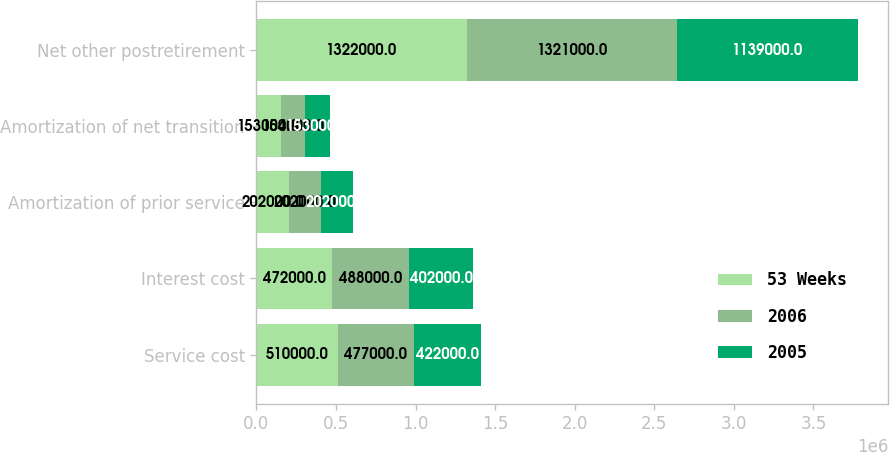<chart> <loc_0><loc_0><loc_500><loc_500><stacked_bar_chart><ecel><fcel>Service cost<fcel>Interest cost<fcel>Amortization of prior service<fcel>Amortization of net transition<fcel>Net other postretirement<nl><fcel>53 Weeks<fcel>510000<fcel>472000<fcel>202000<fcel>153000<fcel>1.322e+06<nl><fcel>2006<fcel>477000<fcel>488000<fcel>202000<fcel>154000<fcel>1.321e+06<nl><fcel>2005<fcel>422000<fcel>402000<fcel>202000<fcel>153000<fcel>1.139e+06<nl></chart> 